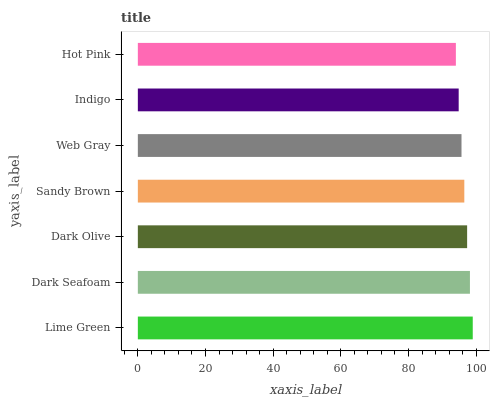Is Hot Pink the minimum?
Answer yes or no. Yes. Is Lime Green the maximum?
Answer yes or no. Yes. Is Dark Seafoam the minimum?
Answer yes or no. No. Is Dark Seafoam the maximum?
Answer yes or no. No. Is Lime Green greater than Dark Seafoam?
Answer yes or no. Yes. Is Dark Seafoam less than Lime Green?
Answer yes or no. Yes. Is Dark Seafoam greater than Lime Green?
Answer yes or no. No. Is Lime Green less than Dark Seafoam?
Answer yes or no. No. Is Sandy Brown the high median?
Answer yes or no. Yes. Is Sandy Brown the low median?
Answer yes or no. Yes. Is Indigo the high median?
Answer yes or no. No. Is Hot Pink the low median?
Answer yes or no. No. 